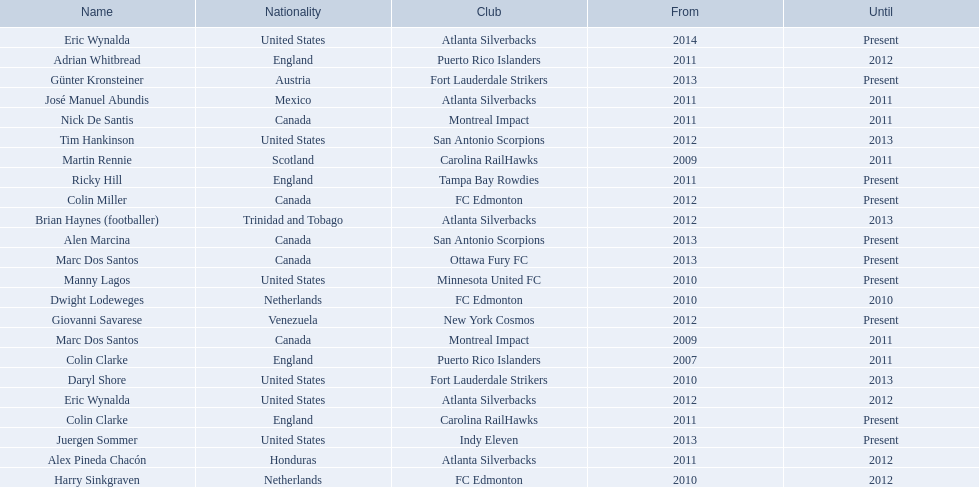What year did marc dos santos start as coach? 2009. Which other starting years correspond with this year? 2009. Who was the other coach with this starting year Martin Rennie. 